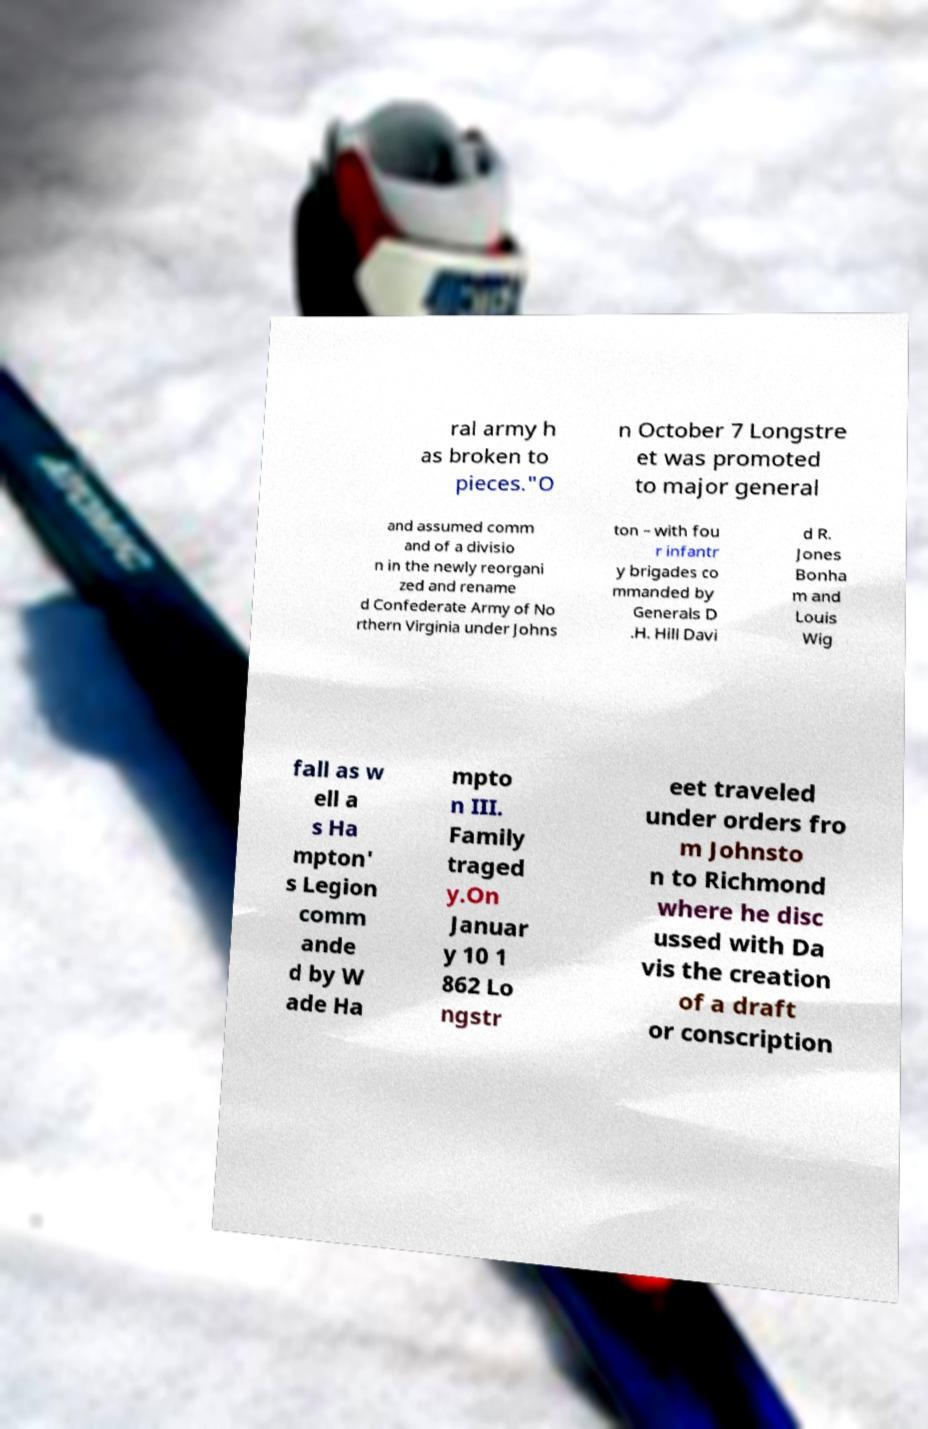What messages or text are displayed in this image? I need them in a readable, typed format. ral army h as broken to pieces."O n October 7 Longstre et was promoted to major general and assumed comm and of a divisio n in the newly reorgani zed and rename d Confederate Army of No rthern Virginia under Johns ton – with fou r infantr y brigades co mmanded by Generals D .H. Hill Davi d R. Jones Bonha m and Louis Wig fall as w ell a s Ha mpton' s Legion comm ande d by W ade Ha mpto n III. Family traged y.On Januar y 10 1 862 Lo ngstr eet traveled under orders fro m Johnsto n to Richmond where he disc ussed with Da vis the creation of a draft or conscription 